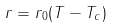Convert formula to latex. <formula><loc_0><loc_0><loc_500><loc_500>r = r _ { 0 } ( T - T _ { c } )</formula> 